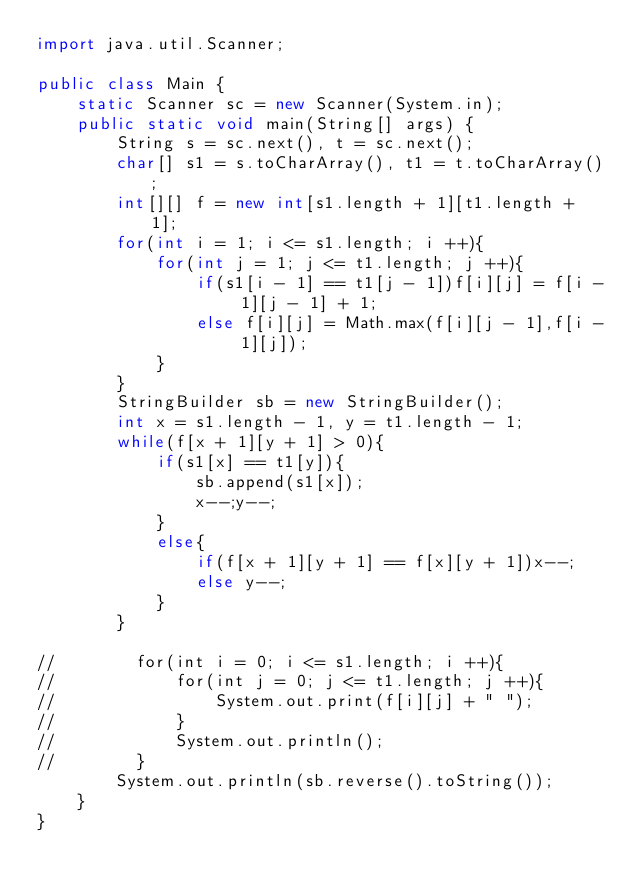<code> <loc_0><loc_0><loc_500><loc_500><_Java_>import java.util.Scanner;

public class Main {
    static Scanner sc = new Scanner(System.in);
    public static void main(String[] args) {
        String s = sc.next(), t = sc.next();
        char[] s1 = s.toCharArray(), t1 = t.toCharArray();
        int[][] f = new int[s1.length + 1][t1.length + 1];
        for(int i = 1; i <= s1.length; i ++){
            for(int j = 1; j <= t1.length; j ++){
                if(s1[i - 1] == t1[j - 1])f[i][j] = f[i - 1][j - 1] + 1;
                else f[i][j] = Math.max(f[i][j - 1],f[i - 1][j]);
            }
        }
        StringBuilder sb = new StringBuilder();
        int x = s1.length - 1, y = t1.length - 1;
        while(f[x + 1][y + 1] > 0){
            if(s1[x] == t1[y]){
                sb.append(s1[x]);
                x--;y--;
            }
            else{
                if(f[x + 1][y + 1] == f[x][y + 1])x--;
                else y--;
            }
        }

//        for(int i = 0; i <= s1.length; i ++){
//            for(int j = 0; j <= t1.length; j ++){
//                System.out.print(f[i][j] + " ");
//            }
//            System.out.println();
//        }
        System.out.println(sb.reverse().toString());
    }
}
</code> 